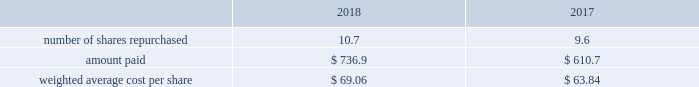Republic services , inc .
Notes to consolidated financial statements 2014 ( continued ) 12 .
Share repurchases and dividends share repurchases share repurchase activity during the years ended december 31 , 2018 and 2017 follows ( in millions except per share amounts ) : .
As of december 31 , 2018 , there were no repurchased shares pending settlement .
In october 2017 , our board of directors added $ 2.0 billion to the existing share repurchase authorization that now extends through december 31 , 2020 .
Share repurchases under the program may be made through open market purchases or privately negotiated transactions in accordance with applicable federal securities laws .
While the board of directors has approved the program , the timing of any purchases , the prices and the number of shares of common stock to be purchased will be determined by our management , at its discretion , and will depend upon market conditions and other factors .
The share repurchase program may be extended , suspended or discontinued at any time .
As of december 31 , 2018 , the remaining authorized purchase capacity under our october 2017 repurchase program was $ 1.1 billion .
Dividends in october 2018 , our board of directors approved a quarterly dividend of $ 0.375 per share .
Cash dividends declared were $ 468.4 million , $ 446.3 million and $ 423.8 million for the years ended december 31 , 2018 , 2017 and 2016 , respectively .
As of december 31 , 2018 , we recorded a quarterly dividend payable of $ 121.0 million to shareholders of record at the close of business on january 2 , 2019 .
13 .
Earnings per share basic earnings per share is computed by dividing net income attributable to republic services , inc .
By the weighted average number of common shares ( including vested but unissued rsus ) outstanding during the period .
Diluted earnings per share is based on the combined weighted average number of common shares and common share equivalents outstanding , which include , where appropriate , the assumed exercise of employee stock options , unvested rsus and unvested psus at the expected attainment levels .
We use the treasury stock method in computing diluted earnings per share. .
What was the total cash dividend declared from 2016 to 2018? 
Rationale: the total amount is the sum of the amounts for each period
Computations: (423.8 + (468.4 + 446.3))
Answer: 1338.5. Republic services , inc .
Notes to consolidated financial statements 2014 ( continued ) 12 .
Share repurchases and dividends share repurchases share repurchase activity during the years ended december 31 , 2018 and 2017 follows ( in millions except per share amounts ) : .
As of december 31 , 2018 , there were no repurchased shares pending settlement .
In october 2017 , our board of directors added $ 2.0 billion to the existing share repurchase authorization that now extends through december 31 , 2020 .
Share repurchases under the program may be made through open market purchases or privately negotiated transactions in accordance with applicable federal securities laws .
While the board of directors has approved the program , the timing of any purchases , the prices and the number of shares of common stock to be purchased will be determined by our management , at its discretion , and will depend upon market conditions and other factors .
The share repurchase program may be extended , suspended or discontinued at any time .
As of december 31 , 2018 , the remaining authorized purchase capacity under our october 2017 repurchase program was $ 1.1 billion .
Dividends in october 2018 , our board of directors approved a quarterly dividend of $ 0.375 per share .
Cash dividends declared were $ 468.4 million , $ 446.3 million and $ 423.8 million for the years ended december 31 , 2018 , 2017 and 2016 , respectively .
As of december 31 , 2018 , we recorded a quarterly dividend payable of $ 121.0 million to shareholders of record at the close of business on january 2 , 2019 .
13 .
Earnings per share basic earnings per share is computed by dividing net income attributable to republic services , inc .
By the weighted average number of common shares ( including vested but unissued rsus ) outstanding during the period .
Diluted earnings per share is based on the combined weighted average number of common shares and common share equivalents outstanding , which include , where appropriate , the assumed exercise of employee stock options , unvested rsus and unvested psus at the expected attainment levels .
We use the treasury stock method in computing diluted earnings per share. .
Between 2018 and 2017 what was the percent change in the weighted average cost per share? 
Rationale: the percentage change is the difference between the 2 periods divide by the earliest period
Computations: ((69.06 - 63.84) / 63.84)
Answer: 0.08177. 